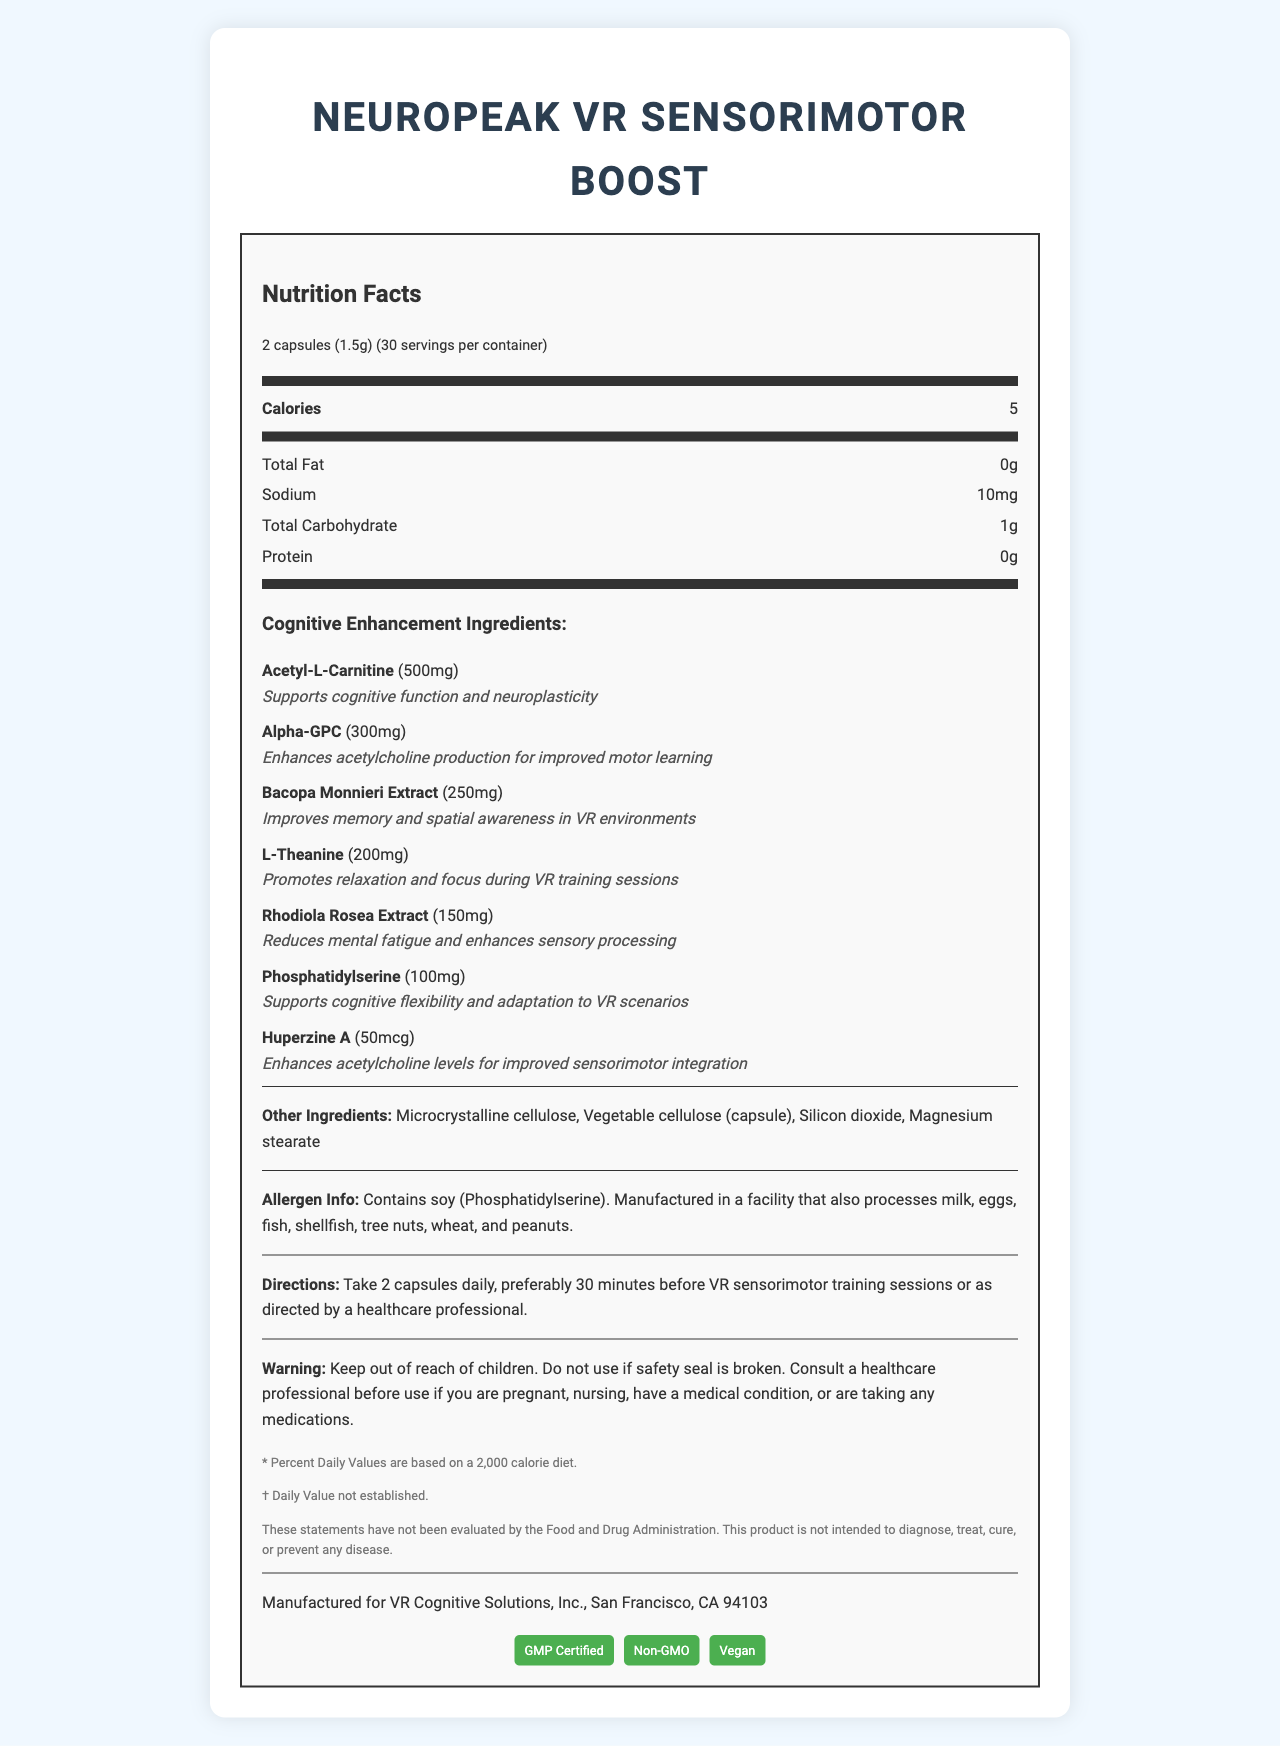what is the serving size for NeuroPeak VR Sensorimotor Boost? The serving size is listed in the nutrition facts label as "2 capsules (1.5g)."
Answer: 2 capsules (1.5g) how many calories are in one serving of the supplement? The nutrition label specifies that there are 5 calories per serving.
Answer: 5 how many servings are there per container? The document states that there are 30 servings per container.
Answer: 30 what is the amount of Acetyl-L-Carnitine in each serving? The ingredient list shows that each serving contains 500mg of Acetyl-L-Carnitine.
Answer: 500mg which ingredient helps with memory and spatial awareness in VR environments? The ingredient listed with the benefit of improving memory and spatial awareness in VR environments is Bacopa Monnieri Extract.
Answer: Bacopa Monnieri Extract which ingredient has the lowest amount per serving? A. Rhodiola Rosea Extract B. Huperzine A C. L-Theanine D. Phosphatidylserine Huperzine A has the lowest amount per serving at 50mcg, compared to the other options with higher amounts.
Answer: B. Huperzine A what is the function of L-Theanine in this supplement? The ingredient list indicates that L-Theanine promotes relaxation and focus during VR training sessions.
Answer: Promotes relaxation and focus during VR training sessions are there any allergens in this product? The allergen information states that the product contains soy (Phosphatidylserine) and may be processed in a facility that handles other common allergens.
Answer: Yes which certification is not listed for this product? A. Organic B. GMP Certified C. Non-GMO D. Vegan The certifications listed are GMP Certified, Non-GMO, and Vegan. Organic is not listed.
Answer: A. Organic when should the supplement be taken for optimal results? The directions state that the supplement should preferably be taken 30 minutes before VR sensorimotor training sessions.
Answer: 30 minutes before VR sensorimotor training sessions who manufactures this supplement? The manufacturer information at the bottom of the document states that it is manufactured for VR Cognitive Solutions, Inc.
Answer: VR Cognitive Solutions, Inc., San Francisco, CA 94103 does the product contain any protein? The nutrition facts label indicates that there is 0g of protein per serving.
Answer: No summarize the main idea of the document. The document provides a complete overview of the supplement, including nutritional information, cognitive enhancement ingredients and their benefits, allergen warnings, and instructions for usage to optimize VR training sessions.
Answer: The document is a nutrition facts label for NeuroPeak VR Sensorimotor Boost, a supplement designed to enhance cognitive functions and sensorimotor integration in VR. It includes detailed information about serving size, ingredients, allergens, and usage directions, along with certifications and manufacturer’s information. is there any mention of FDA approval for the product claims? The disclaimers state that "These statements have not been evaluated by the Food and Drug Administration," indicating that the FDA has not approved the product claims.
Answer: No what is the benefit of using Phosphatidylserine in the supplement? The ingredient list includes Phosphatidylserine and notes that it supports cognitive flexibility and adaptation to VR scenarios.
Answer: Supports cognitive flexibility and adaptation to VR scenarios can we determine if the supplement is safe for pregnant women? The warning statement advises consulting a healthcare professional if pregnant, indicating that safety for pregnant women cannot be determined from the document alone.
Answer: Not enough information describe the allergen manufacturing conditions mentioned. The allergen information indicates that, in addition to containing soy, the product is manufactured in a facility that handles various common allergens.
Answer: The product is manufactured in a facility that also processes milk, eggs, fish, shellfish, tree nuts, wheat, and peanuts 